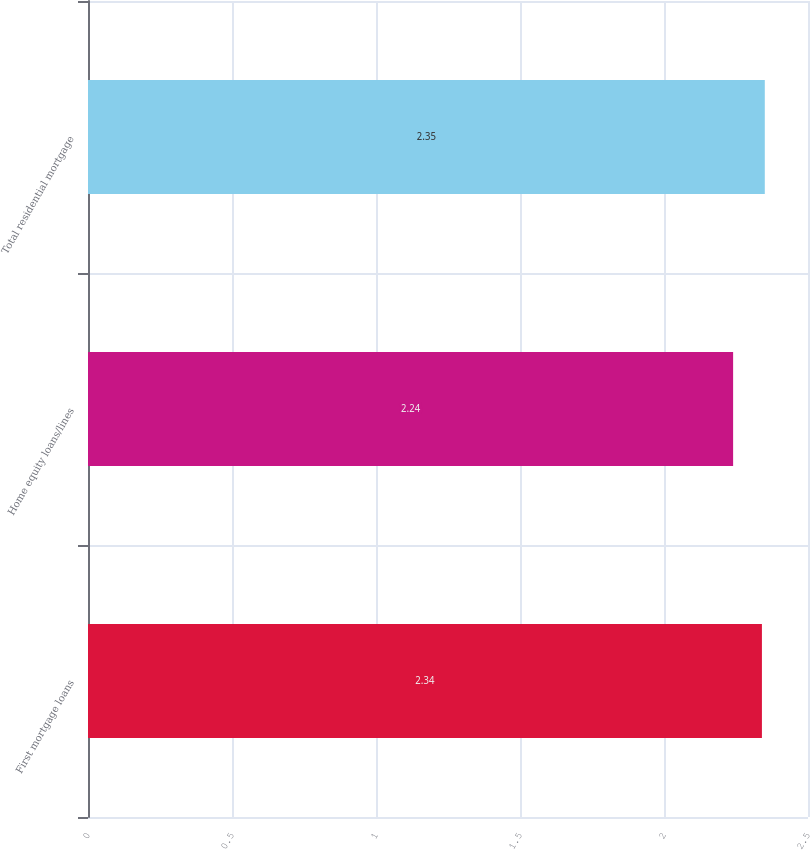Convert chart. <chart><loc_0><loc_0><loc_500><loc_500><bar_chart><fcel>First mortgage loans<fcel>Home equity loans/lines<fcel>Total residential mortgage<nl><fcel>2.34<fcel>2.24<fcel>2.35<nl></chart> 